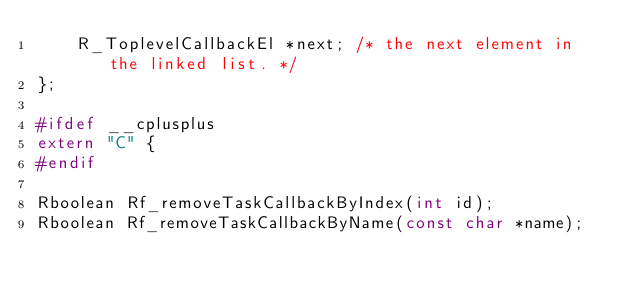<code> <loc_0><loc_0><loc_500><loc_500><_C_>    R_ToplevelCallbackEl *next; /* the next element in the linked list. */
};

#ifdef __cplusplus
extern "C" {
#endif

Rboolean Rf_removeTaskCallbackByIndex(int id);
Rboolean Rf_removeTaskCallbackByName(const char *name);</code> 